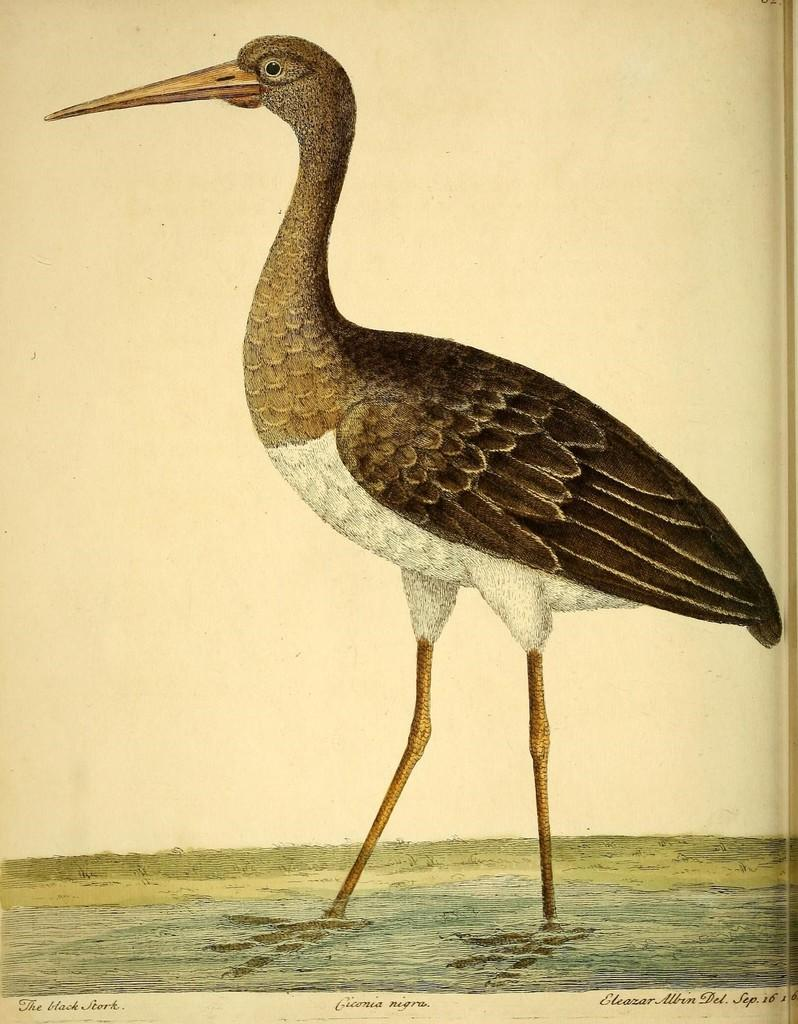What is the main subject of the image? The image contains a painting. What is depicted in the painting? A bird is standing in water in the painting. Is there any text associated with the image? Yes, there is some text at the bottom of the image. What type of grass can be seen growing around the bird in the image? There is no grass visible in the image; it features a painting of a bird standing in water. What color is the gold object that the bird is holding in the image? There is no gold object present in the image; the bird is standing in water in a painting. 